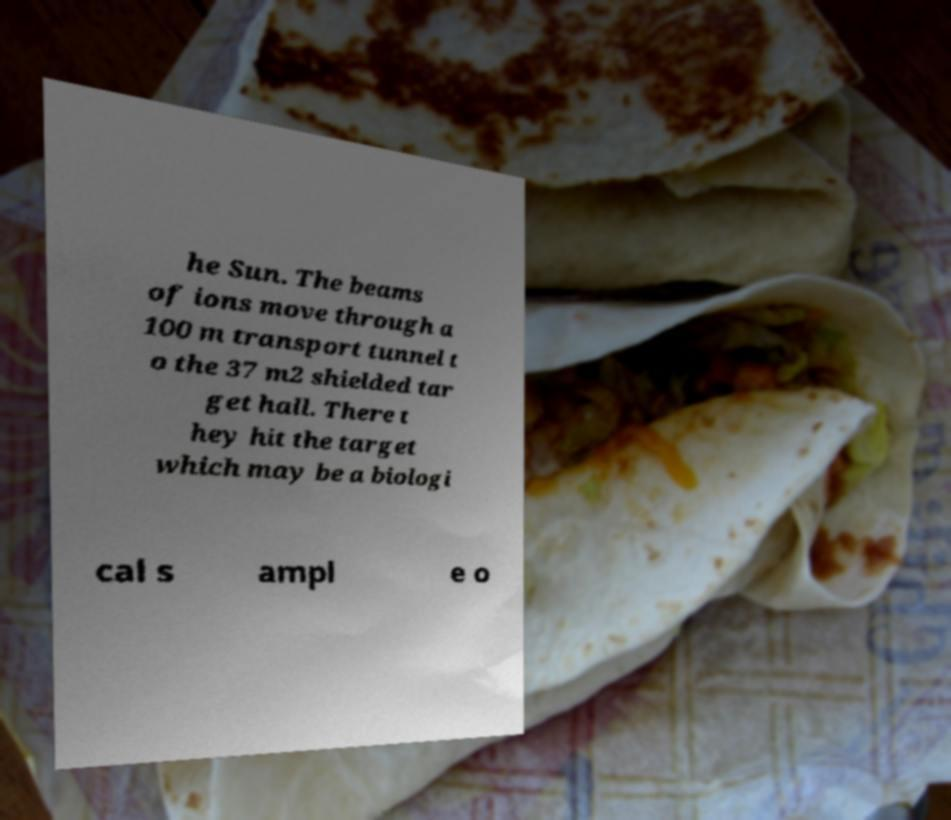Could you extract and type out the text from this image? he Sun. The beams of ions move through a 100 m transport tunnel t o the 37 m2 shielded tar get hall. There t hey hit the target which may be a biologi cal s ampl e o 